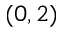<formula> <loc_0><loc_0><loc_500><loc_500>( 0 , 2 )</formula> 